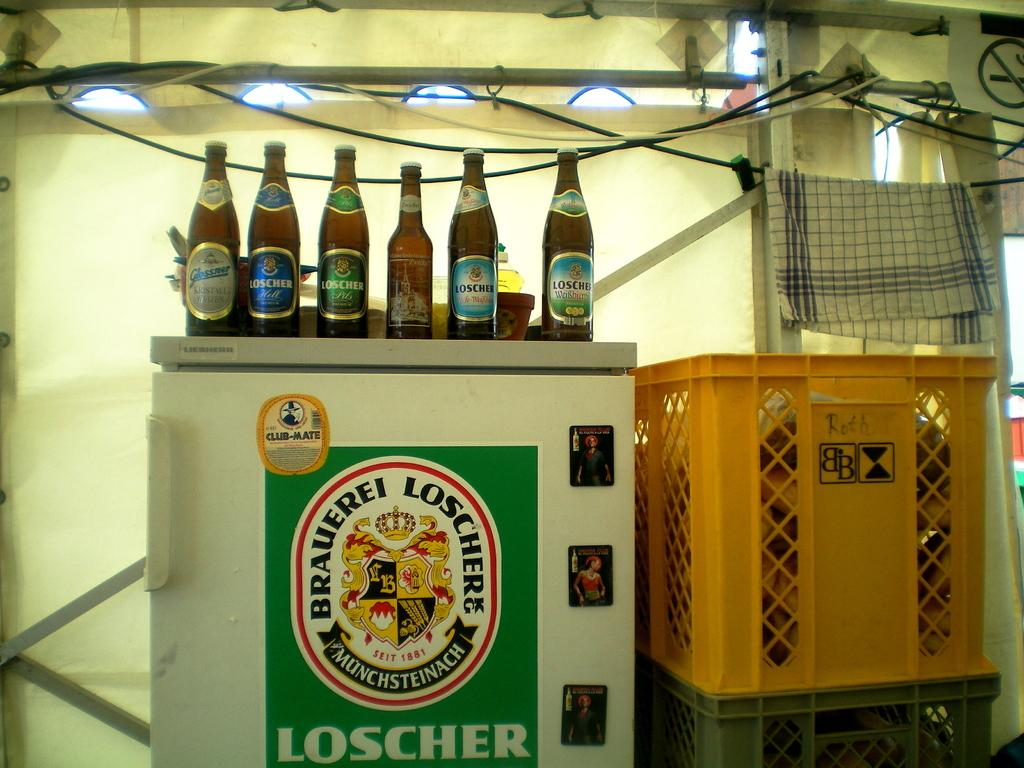<image>
Write a terse but informative summary of the picture. A fridge with decorated Loschere various varieties on top of it 